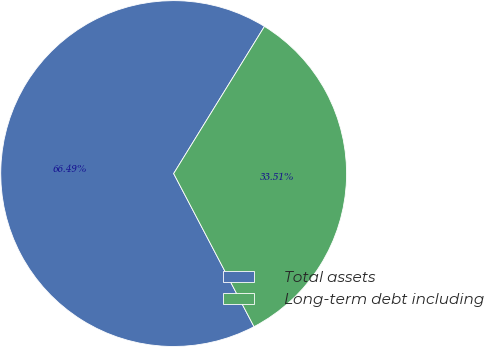Convert chart to OTSL. <chart><loc_0><loc_0><loc_500><loc_500><pie_chart><fcel>Total assets<fcel>Long-term debt including<nl><fcel>66.49%<fcel>33.51%<nl></chart> 